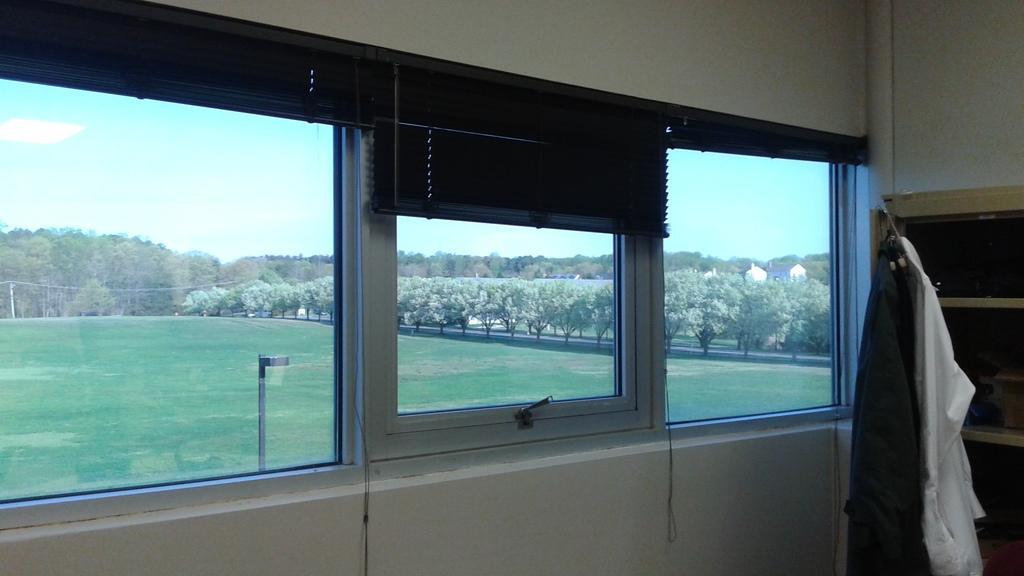In one or two sentences, can you explain what this image depicts? There is a room and the clothes are hanged beside a storage rack and there are three windows, behind the windows there is a beautiful garden with plenty of trees. 